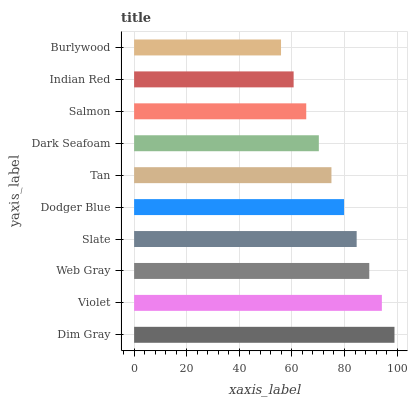Is Burlywood the minimum?
Answer yes or no. Yes. Is Dim Gray the maximum?
Answer yes or no. Yes. Is Violet the minimum?
Answer yes or no. No. Is Violet the maximum?
Answer yes or no. No. Is Dim Gray greater than Violet?
Answer yes or no. Yes. Is Violet less than Dim Gray?
Answer yes or no. Yes. Is Violet greater than Dim Gray?
Answer yes or no. No. Is Dim Gray less than Violet?
Answer yes or no. No. Is Dodger Blue the high median?
Answer yes or no. Yes. Is Tan the low median?
Answer yes or no. Yes. Is Dim Gray the high median?
Answer yes or no. No. Is Dodger Blue the low median?
Answer yes or no. No. 